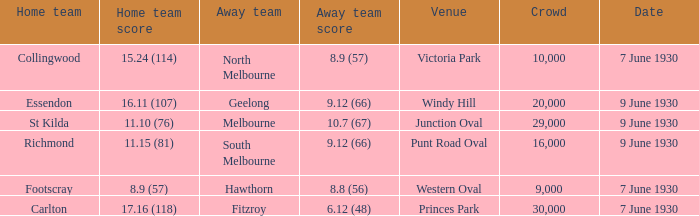What is the average crowd size when North Melbourne is the away team? 10000.0. 